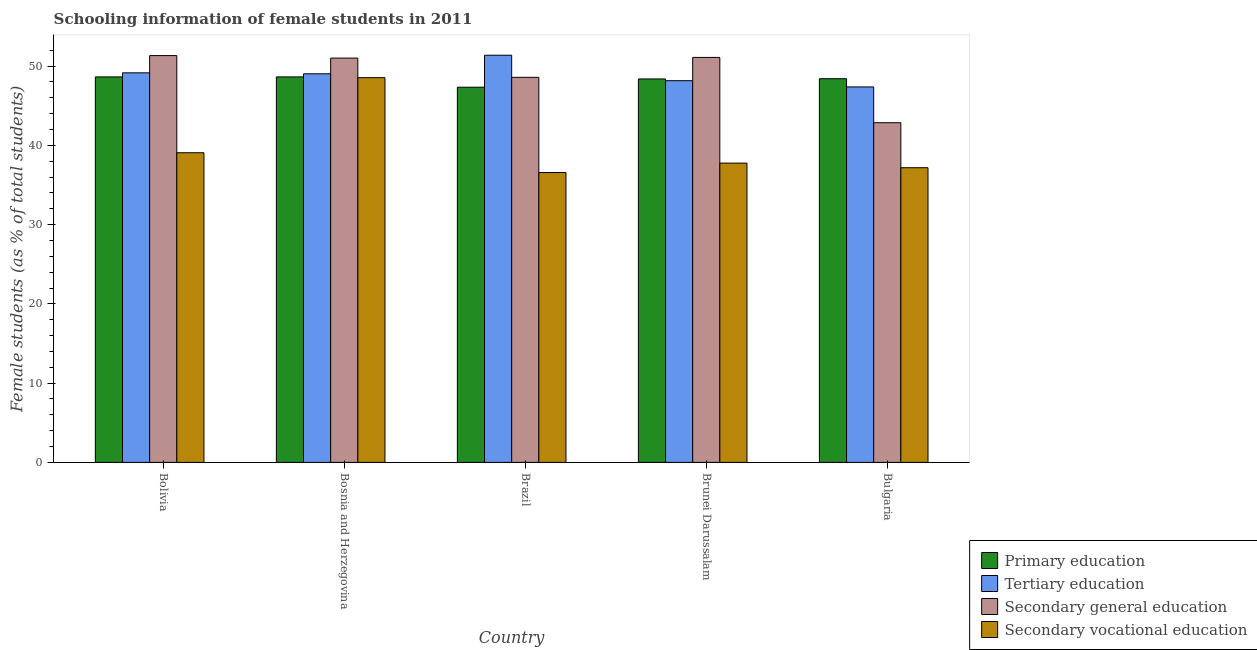How many different coloured bars are there?
Provide a short and direct response. 4. How many groups of bars are there?
Make the answer very short. 5. Are the number of bars per tick equal to the number of legend labels?
Provide a succinct answer. Yes. How many bars are there on the 2nd tick from the left?
Offer a very short reply. 4. How many bars are there on the 2nd tick from the right?
Keep it short and to the point. 4. What is the label of the 1st group of bars from the left?
Provide a succinct answer. Bolivia. What is the percentage of female students in secondary education in Bulgaria?
Provide a succinct answer. 42.86. Across all countries, what is the maximum percentage of female students in primary education?
Offer a terse response. 48.63. Across all countries, what is the minimum percentage of female students in secondary education?
Make the answer very short. 42.86. What is the total percentage of female students in tertiary education in the graph?
Your response must be concise. 245.07. What is the difference between the percentage of female students in primary education in Bolivia and that in Bulgaria?
Your answer should be very brief. 0.23. What is the difference between the percentage of female students in tertiary education in Brunei Darussalam and the percentage of female students in secondary education in Bosnia and Herzegovina?
Make the answer very short. -2.85. What is the average percentage of female students in tertiary education per country?
Your answer should be very brief. 49.01. What is the difference between the percentage of female students in secondary vocational education and percentage of female students in secondary education in Bulgaria?
Give a very brief answer. -5.68. What is the ratio of the percentage of female students in secondary education in Bosnia and Herzegovina to that in Bulgaria?
Make the answer very short. 1.19. Is the difference between the percentage of female students in secondary education in Brazil and Brunei Darussalam greater than the difference between the percentage of female students in secondary vocational education in Brazil and Brunei Darussalam?
Offer a very short reply. No. What is the difference between the highest and the second highest percentage of female students in secondary education?
Provide a short and direct response. 0.23. What is the difference between the highest and the lowest percentage of female students in primary education?
Your response must be concise. 1.3. Is the sum of the percentage of female students in secondary vocational education in Bosnia and Herzegovina and Brazil greater than the maximum percentage of female students in tertiary education across all countries?
Offer a terse response. Yes. Is it the case that in every country, the sum of the percentage of female students in secondary vocational education and percentage of female students in primary education is greater than the sum of percentage of female students in tertiary education and percentage of female students in secondary education?
Ensure brevity in your answer.  Yes. What does the 1st bar from the left in Brazil represents?
Ensure brevity in your answer.  Primary education. What does the 1st bar from the right in Brazil represents?
Offer a terse response. Secondary vocational education. Is it the case that in every country, the sum of the percentage of female students in primary education and percentage of female students in tertiary education is greater than the percentage of female students in secondary education?
Offer a very short reply. Yes. Are all the bars in the graph horizontal?
Provide a short and direct response. No. How many countries are there in the graph?
Provide a short and direct response. 5. What is the difference between two consecutive major ticks on the Y-axis?
Keep it short and to the point. 10. Are the values on the major ticks of Y-axis written in scientific E-notation?
Your answer should be very brief. No. Does the graph contain grids?
Keep it short and to the point. No. Where does the legend appear in the graph?
Provide a short and direct response. Bottom right. How many legend labels are there?
Make the answer very short. 4. How are the legend labels stacked?
Provide a short and direct response. Vertical. What is the title of the graph?
Offer a terse response. Schooling information of female students in 2011. What is the label or title of the Y-axis?
Offer a terse response. Female students (as % of total students). What is the Female students (as % of total students) in Primary education in Bolivia?
Your answer should be compact. 48.63. What is the Female students (as % of total students) in Tertiary education in Bolivia?
Your answer should be very brief. 49.15. What is the Female students (as % of total students) of Secondary general education in Bolivia?
Give a very brief answer. 51.32. What is the Female students (as % of total students) of Secondary vocational education in Bolivia?
Offer a terse response. 39.06. What is the Female students (as % of total students) in Primary education in Bosnia and Herzegovina?
Provide a short and direct response. 48.63. What is the Female students (as % of total students) in Tertiary education in Bosnia and Herzegovina?
Offer a terse response. 49.03. What is the Female students (as % of total students) of Secondary general education in Bosnia and Herzegovina?
Your answer should be compact. 51.01. What is the Female students (as % of total students) of Secondary vocational education in Bosnia and Herzegovina?
Offer a terse response. 48.54. What is the Female students (as % of total students) of Primary education in Brazil?
Your answer should be very brief. 47.33. What is the Female students (as % of total students) in Tertiary education in Brazil?
Ensure brevity in your answer.  51.37. What is the Female students (as % of total students) in Secondary general education in Brazil?
Provide a succinct answer. 48.58. What is the Female students (as % of total students) of Secondary vocational education in Brazil?
Offer a terse response. 36.57. What is the Female students (as % of total students) in Primary education in Brunei Darussalam?
Your response must be concise. 48.38. What is the Female students (as % of total students) in Tertiary education in Brunei Darussalam?
Your response must be concise. 48.15. What is the Female students (as % of total students) of Secondary general education in Brunei Darussalam?
Your answer should be compact. 51.09. What is the Female students (as % of total students) of Secondary vocational education in Brunei Darussalam?
Your response must be concise. 37.76. What is the Female students (as % of total students) in Primary education in Bulgaria?
Provide a short and direct response. 48.4. What is the Female students (as % of total students) of Tertiary education in Bulgaria?
Your response must be concise. 47.37. What is the Female students (as % of total students) of Secondary general education in Bulgaria?
Provide a short and direct response. 42.86. What is the Female students (as % of total students) in Secondary vocational education in Bulgaria?
Your response must be concise. 37.17. Across all countries, what is the maximum Female students (as % of total students) in Primary education?
Your answer should be very brief. 48.63. Across all countries, what is the maximum Female students (as % of total students) of Tertiary education?
Your response must be concise. 51.37. Across all countries, what is the maximum Female students (as % of total students) of Secondary general education?
Make the answer very short. 51.32. Across all countries, what is the maximum Female students (as % of total students) in Secondary vocational education?
Offer a very short reply. 48.54. Across all countries, what is the minimum Female students (as % of total students) in Primary education?
Offer a very short reply. 47.33. Across all countries, what is the minimum Female students (as % of total students) of Tertiary education?
Keep it short and to the point. 47.37. Across all countries, what is the minimum Female students (as % of total students) in Secondary general education?
Ensure brevity in your answer.  42.86. Across all countries, what is the minimum Female students (as % of total students) in Secondary vocational education?
Provide a short and direct response. 36.57. What is the total Female students (as % of total students) in Primary education in the graph?
Provide a short and direct response. 241.38. What is the total Female students (as % of total students) in Tertiary education in the graph?
Your answer should be very brief. 245.07. What is the total Female students (as % of total students) in Secondary general education in the graph?
Ensure brevity in your answer.  244.86. What is the total Female students (as % of total students) in Secondary vocational education in the graph?
Give a very brief answer. 199.11. What is the difference between the Female students (as % of total students) in Primary education in Bolivia and that in Bosnia and Herzegovina?
Make the answer very short. -0. What is the difference between the Female students (as % of total students) in Tertiary education in Bolivia and that in Bosnia and Herzegovina?
Your answer should be compact. 0.12. What is the difference between the Female students (as % of total students) in Secondary general education in Bolivia and that in Bosnia and Herzegovina?
Your answer should be compact. 0.32. What is the difference between the Female students (as % of total students) of Secondary vocational education in Bolivia and that in Bosnia and Herzegovina?
Your response must be concise. -9.47. What is the difference between the Female students (as % of total students) in Primary education in Bolivia and that in Brazil?
Ensure brevity in your answer.  1.3. What is the difference between the Female students (as % of total students) of Tertiary education in Bolivia and that in Brazil?
Provide a short and direct response. -2.22. What is the difference between the Female students (as % of total students) of Secondary general education in Bolivia and that in Brazil?
Provide a succinct answer. 2.74. What is the difference between the Female students (as % of total students) in Secondary vocational education in Bolivia and that in Brazil?
Provide a short and direct response. 2.49. What is the difference between the Female students (as % of total students) of Primary education in Bolivia and that in Brunei Darussalam?
Your answer should be very brief. 0.26. What is the difference between the Female students (as % of total students) of Secondary general education in Bolivia and that in Brunei Darussalam?
Make the answer very short. 0.23. What is the difference between the Female students (as % of total students) in Secondary vocational education in Bolivia and that in Brunei Darussalam?
Keep it short and to the point. 1.31. What is the difference between the Female students (as % of total students) of Primary education in Bolivia and that in Bulgaria?
Offer a terse response. 0.23. What is the difference between the Female students (as % of total students) in Tertiary education in Bolivia and that in Bulgaria?
Your response must be concise. 1.78. What is the difference between the Female students (as % of total students) of Secondary general education in Bolivia and that in Bulgaria?
Ensure brevity in your answer.  8.47. What is the difference between the Female students (as % of total students) in Secondary vocational education in Bolivia and that in Bulgaria?
Offer a very short reply. 1.89. What is the difference between the Female students (as % of total students) of Primary education in Bosnia and Herzegovina and that in Brazil?
Your answer should be very brief. 1.3. What is the difference between the Female students (as % of total students) in Tertiary education in Bosnia and Herzegovina and that in Brazil?
Make the answer very short. -2.34. What is the difference between the Female students (as % of total students) in Secondary general education in Bosnia and Herzegovina and that in Brazil?
Offer a very short reply. 2.43. What is the difference between the Female students (as % of total students) in Secondary vocational education in Bosnia and Herzegovina and that in Brazil?
Keep it short and to the point. 11.97. What is the difference between the Female students (as % of total students) in Primary education in Bosnia and Herzegovina and that in Brunei Darussalam?
Your answer should be very brief. 0.26. What is the difference between the Female students (as % of total students) in Tertiary education in Bosnia and Herzegovina and that in Brunei Darussalam?
Your answer should be compact. 0.87. What is the difference between the Female students (as % of total students) in Secondary general education in Bosnia and Herzegovina and that in Brunei Darussalam?
Give a very brief answer. -0.09. What is the difference between the Female students (as % of total students) in Secondary vocational education in Bosnia and Herzegovina and that in Brunei Darussalam?
Provide a succinct answer. 10.78. What is the difference between the Female students (as % of total students) in Primary education in Bosnia and Herzegovina and that in Bulgaria?
Your answer should be compact. 0.23. What is the difference between the Female students (as % of total students) of Tertiary education in Bosnia and Herzegovina and that in Bulgaria?
Offer a terse response. 1.66. What is the difference between the Female students (as % of total students) in Secondary general education in Bosnia and Herzegovina and that in Bulgaria?
Provide a short and direct response. 8.15. What is the difference between the Female students (as % of total students) of Secondary vocational education in Bosnia and Herzegovina and that in Bulgaria?
Your response must be concise. 11.36. What is the difference between the Female students (as % of total students) in Primary education in Brazil and that in Brunei Darussalam?
Give a very brief answer. -1.04. What is the difference between the Female students (as % of total students) of Tertiary education in Brazil and that in Brunei Darussalam?
Provide a succinct answer. 3.21. What is the difference between the Female students (as % of total students) in Secondary general education in Brazil and that in Brunei Darussalam?
Offer a very short reply. -2.51. What is the difference between the Female students (as % of total students) in Secondary vocational education in Brazil and that in Brunei Darussalam?
Give a very brief answer. -1.19. What is the difference between the Female students (as % of total students) of Primary education in Brazil and that in Bulgaria?
Ensure brevity in your answer.  -1.07. What is the difference between the Female students (as % of total students) of Tertiary education in Brazil and that in Bulgaria?
Your response must be concise. 4. What is the difference between the Female students (as % of total students) of Secondary general education in Brazil and that in Bulgaria?
Keep it short and to the point. 5.72. What is the difference between the Female students (as % of total students) in Secondary vocational education in Brazil and that in Bulgaria?
Your response must be concise. -0.6. What is the difference between the Female students (as % of total students) in Primary education in Brunei Darussalam and that in Bulgaria?
Provide a short and direct response. -0.03. What is the difference between the Female students (as % of total students) in Tertiary education in Brunei Darussalam and that in Bulgaria?
Your response must be concise. 0.79. What is the difference between the Female students (as % of total students) of Secondary general education in Brunei Darussalam and that in Bulgaria?
Keep it short and to the point. 8.24. What is the difference between the Female students (as % of total students) in Secondary vocational education in Brunei Darussalam and that in Bulgaria?
Give a very brief answer. 0.58. What is the difference between the Female students (as % of total students) of Primary education in Bolivia and the Female students (as % of total students) of Tertiary education in Bosnia and Herzegovina?
Ensure brevity in your answer.  -0.4. What is the difference between the Female students (as % of total students) of Primary education in Bolivia and the Female students (as % of total students) of Secondary general education in Bosnia and Herzegovina?
Provide a succinct answer. -2.38. What is the difference between the Female students (as % of total students) in Primary education in Bolivia and the Female students (as % of total students) in Secondary vocational education in Bosnia and Herzegovina?
Your answer should be very brief. 0.09. What is the difference between the Female students (as % of total students) of Tertiary education in Bolivia and the Female students (as % of total students) of Secondary general education in Bosnia and Herzegovina?
Ensure brevity in your answer.  -1.86. What is the difference between the Female students (as % of total students) of Tertiary education in Bolivia and the Female students (as % of total students) of Secondary vocational education in Bosnia and Herzegovina?
Your answer should be very brief. 0.61. What is the difference between the Female students (as % of total students) of Secondary general education in Bolivia and the Female students (as % of total students) of Secondary vocational education in Bosnia and Herzegovina?
Your answer should be compact. 2.79. What is the difference between the Female students (as % of total students) of Primary education in Bolivia and the Female students (as % of total students) of Tertiary education in Brazil?
Offer a terse response. -2.74. What is the difference between the Female students (as % of total students) of Primary education in Bolivia and the Female students (as % of total students) of Secondary general education in Brazil?
Your response must be concise. 0.05. What is the difference between the Female students (as % of total students) of Primary education in Bolivia and the Female students (as % of total students) of Secondary vocational education in Brazil?
Keep it short and to the point. 12.06. What is the difference between the Female students (as % of total students) of Tertiary education in Bolivia and the Female students (as % of total students) of Secondary general education in Brazil?
Offer a very short reply. 0.57. What is the difference between the Female students (as % of total students) of Tertiary education in Bolivia and the Female students (as % of total students) of Secondary vocational education in Brazil?
Keep it short and to the point. 12.58. What is the difference between the Female students (as % of total students) in Secondary general education in Bolivia and the Female students (as % of total students) in Secondary vocational education in Brazil?
Offer a very short reply. 14.75. What is the difference between the Female students (as % of total students) of Primary education in Bolivia and the Female students (as % of total students) of Tertiary education in Brunei Darussalam?
Ensure brevity in your answer.  0.48. What is the difference between the Female students (as % of total students) of Primary education in Bolivia and the Female students (as % of total students) of Secondary general education in Brunei Darussalam?
Give a very brief answer. -2.46. What is the difference between the Female students (as % of total students) of Primary education in Bolivia and the Female students (as % of total students) of Secondary vocational education in Brunei Darussalam?
Give a very brief answer. 10.87. What is the difference between the Female students (as % of total students) of Tertiary education in Bolivia and the Female students (as % of total students) of Secondary general education in Brunei Darussalam?
Ensure brevity in your answer.  -1.95. What is the difference between the Female students (as % of total students) of Tertiary education in Bolivia and the Female students (as % of total students) of Secondary vocational education in Brunei Darussalam?
Offer a terse response. 11.39. What is the difference between the Female students (as % of total students) of Secondary general education in Bolivia and the Female students (as % of total students) of Secondary vocational education in Brunei Darussalam?
Keep it short and to the point. 13.56. What is the difference between the Female students (as % of total students) in Primary education in Bolivia and the Female students (as % of total students) in Tertiary education in Bulgaria?
Give a very brief answer. 1.26. What is the difference between the Female students (as % of total students) in Primary education in Bolivia and the Female students (as % of total students) in Secondary general education in Bulgaria?
Keep it short and to the point. 5.78. What is the difference between the Female students (as % of total students) in Primary education in Bolivia and the Female students (as % of total students) in Secondary vocational education in Bulgaria?
Your answer should be compact. 11.46. What is the difference between the Female students (as % of total students) in Tertiary education in Bolivia and the Female students (as % of total students) in Secondary general education in Bulgaria?
Make the answer very short. 6.29. What is the difference between the Female students (as % of total students) of Tertiary education in Bolivia and the Female students (as % of total students) of Secondary vocational education in Bulgaria?
Provide a succinct answer. 11.97. What is the difference between the Female students (as % of total students) in Secondary general education in Bolivia and the Female students (as % of total students) in Secondary vocational education in Bulgaria?
Your answer should be compact. 14.15. What is the difference between the Female students (as % of total students) of Primary education in Bosnia and Herzegovina and the Female students (as % of total students) of Tertiary education in Brazil?
Your response must be concise. -2.73. What is the difference between the Female students (as % of total students) of Primary education in Bosnia and Herzegovina and the Female students (as % of total students) of Secondary general education in Brazil?
Keep it short and to the point. 0.05. What is the difference between the Female students (as % of total students) in Primary education in Bosnia and Herzegovina and the Female students (as % of total students) in Secondary vocational education in Brazil?
Offer a very short reply. 12.06. What is the difference between the Female students (as % of total students) of Tertiary education in Bosnia and Herzegovina and the Female students (as % of total students) of Secondary general education in Brazil?
Give a very brief answer. 0.45. What is the difference between the Female students (as % of total students) of Tertiary education in Bosnia and Herzegovina and the Female students (as % of total students) of Secondary vocational education in Brazil?
Your answer should be compact. 12.46. What is the difference between the Female students (as % of total students) of Secondary general education in Bosnia and Herzegovina and the Female students (as % of total students) of Secondary vocational education in Brazil?
Your response must be concise. 14.44. What is the difference between the Female students (as % of total students) of Primary education in Bosnia and Herzegovina and the Female students (as % of total students) of Tertiary education in Brunei Darussalam?
Provide a short and direct response. 0.48. What is the difference between the Female students (as % of total students) in Primary education in Bosnia and Herzegovina and the Female students (as % of total students) in Secondary general education in Brunei Darussalam?
Keep it short and to the point. -2.46. What is the difference between the Female students (as % of total students) of Primary education in Bosnia and Herzegovina and the Female students (as % of total students) of Secondary vocational education in Brunei Darussalam?
Your response must be concise. 10.87. What is the difference between the Female students (as % of total students) in Tertiary education in Bosnia and Herzegovina and the Female students (as % of total students) in Secondary general education in Brunei Darussalam?
Give a very brief answer. -2.07. What is the difference between the Female students (as % of total students) in Tertiary education in Bosnia and Herzegovina and the Female students (as % of total students) in Secondary vocational education in Brunei Darussalam?
Give a very brief answer. 11.27. What is the difference between the Female students (as % of total students) in Secondary general education in Bosnia and Herzegovina and the Female students (as % of total students) in Secondary vocational education in Brunei Darussalam?
Your response must be concise. 13.25. What is the difference between the Female students (as % of total students) of Primary education in Bosnia and Herzegovina and the Female students (as % of total students) of Tertiary education in Bulgaria?
Provide a short and direct response. 1.26. What is the difference between the Female students (as % of total students) of Primary education in Bosnia and Herzegovina and the Female students (as % of total students) of Secondary general education in Bulgaria?
Make the answer very short. 5.78. What is the difference between the Female students (as % of total students) of Primary education in Bosnia and Herzegovina and the Female students (as % of total students) of Secondary vocational education in Bulgaria?
Your answer should be very brief. 11.46. What is the difference between the Female students (as % of total students) in Tertiary education in Bosnia and Herzegovina and the Female students (as % of total students) in Secondary general education in Bulgaria?
Your response must be concise. 6.17. What is the difference between the Female students (as % of total students) of Tertiary education in Bosnia and Herzegovina and the Female students (as % of total students) of Secondary vocational education in Bulgaria?
Your answer should be compact. 11.85. What is the difference between the Female students (as % of total students) of Secondary general education in Bosnia and Herzegovina and the Female students (as % of total students) of Secondary vocational education in Bulgaria?
Offer a very short reply. 13.83. What is the difference between the Female students (as % of total students) of Primary education in Brazil and the Female students (as % of total students) of Tertiary education in Brunei Darussalam?
Your response must be concise. -0.82. What is the difference between the Female students (as % of total students) of Primary education in Brazil and the Female students (as % of total students) of Secondary general education in Brunei Darussalam?
Make the answer very short. -3.76. What is the difference between the Female students (as % of total students) in Primary education in Brazil and the Female students (as % of total students) in Secondary vocational education in Brunei Darussalam?
Make the answer very short. 9.57. What is the difference between the Female students (as % of total students) of Tertiary education in Brazil and the Female students (as % of total students) of Secondary general education in Brunei Darussalam?
Your answer should be compact. 0.27. What is the difference between the Female students (as % of total students) of Tertiary education in Brazil and the Female students (as % of total students) of Secondary vocational education in Brunei Darussalam?
Give a very brief answer. 13.61. What is the difference between the Female students (as % of total students) of Secondary general education in Brazil and the Female students (as % of total students) of Secondary vocational education in Brunei Darussalam?
Your answer should be very brief. 10.82. What is the difference between the Female students (as % of total students) in Primary education in Brazil and the Female students (as % of total students) in Tertiary education in Bulgaria?
Make the answer very short. -0.04. What is the difference between the Female students (as % of total students) in Primary education in Brazil and the Female students (as % of total students) in Secondary general education in Bulgaria?
Provide a succinct answer. 4.48. What is the difference between the Female students (as % of total students) of Primary education in Brazil and the Female students (as % of total students) of Secondary vocational education in Bulgaria?
Your answer should be very brief. 10.16. What is the difference between the Female students (as % of total students) in Tertiary education in Brazil and the Female students (as % of total students) in Secondary general education in Bulgaria?
Ensure brevity in your answer.  8.51. What is the difference between the Female students (as % of total students) in Tertiary education in Brazil and the Female students (as % of total students) in Secondary vocational education in Bulgaria?
Your response must be concise. 14.19. What is the difference between the Female students (as % of total students) of Secondary general education in Brazil and the Female students (as % of total students) of Secondary vocational education in Bulgaria?
Your response must be concise. 11.4. What is the difference between the Female students (as % of total students) of Primary education in Brunei Darussalam and the Female students (as % of total students) of Tertiary education in Bulgaria?
Your response must be concise. 1.01. What is the difference between the Female students (as % of total students) in Primary education in Brunei Darussalam and the Female students (as % of total students) in Secondary general education in Bulgaria?
Your response must be concise. 5.52. What is the difference between the Female students (as % of total students) of Primary education in Brunei Darussalam and the Female students (as % of total students) of Secondary vocational education in Bulgaria?
Make the answer very short. 11.2. What is the difference between the Female students (as % of total students) of Tertiary education in Brunei Darussalam and the Female students (as % of total students) of Secondary general education in Bulgaria?
Your answer should be very brief. 5.3. What is the difference between the Female students (as % of total students) in Tertiary education in Brunei Darussalam and the Female students (as % of total students) in Secondary vocational education in Bulgaria?
Keep it short and to the point. 10.98. What is the difference between the Female students (as % of total students) in Secondary general education in Brunei Darussalam and the Female students (as % of total students) in Secondary vocational education in Bulgaria?
Give a very brief answer. 13.92. What is the average Female students (as % of total students) in Primary education per country?
Ensure brevity in your answer.  48.28. What is the average Female students (as % of total students) in Tertiary education per country?
Provide a succinct answer. 49.01. What is the average Female students (as % of total students) in Secondary general education per country?
Your response must be concise. 48.97. What is the average Female students (as % of total students) of Secondary vocational education per country?
Provide a succinct answer. 39.82. What is the difference between the Female students (as % of total students) of Primary education and Female students (as % of total students) of Tertiary education in Bolivia?
Provide a succinct answer. -0.52. What is the difference between the Female students (as % of total students) in Primary education and Female students (as % of total students) in Secondary general education in Bolivia?
Provide a short and direct response. -2.69. What is the difference between the Female students (as % of total students) in Primary education and Female students (as % of total students) in Secondary vocational education in Bolivia?
Keep it short and to the point. 9.57. What is the difference between the Female students (as % of total students) in Tertiary education and Female students (as % of total students) in Secondary general education in Bolivia?
Keep it short and to the point. -2.18. What is the difference between the Female students (as % of total students) of Tertiary education and Female students (as % of total students) of Secondary vocational education in Bolivia?
Keep it short and to the point. 10.08. What is the difference between the Female students (as % of total students) in Secondary general education and Female students (as % of total students) in Secondary vocational education in Bolivia?
Make the answer very short. 12.26. What is the difference between the Female students (as % of total students) in Primary education and Female students (as % of total students) in Tertiary education in Bosnia and Herzegovina?
Offer a very short reply. -0.39. What is the difference between the Female students (as % of total students) of Primary education and Female students (as % of total students) of Secondary general education in Bosnia and Herzegovina?
Ensure brevity in your answer.  -2.37. What is the difference between the Female students (as % of total students) in Primary education and Female students (as % of total students) in Secondary vocational education in Bosnia and Herzegovina?
Your response must be concise. 0.1. What is the difference between the Female students (as % of total students) in Tertiary education and Female students (as % of total students) in Secondary general education in Bosnia and Herzegovina?
Your response must be concise. -1.98. What is the difference between the Female students (as % of total students) in Tertiary education and Female students (as % of total students) in Secondary vocational education in Bosnia and Herzegovina?
Give a very brief answer. 0.49. What is the difference between the Female students (as % of total students) in Secondary general education and Female students (as % of total students) in Secondary vocational education in Bosnia and Herzegovina?
Your answer should be compact. 2.47. What is the difference between the Female students (as % of total students) of Primary education and Female students (as % of total students) of Tertiary education in Brazil?
Make the answer very short. -4.03. What is the difference between the Female students (as % of total students) in Primary education and Female students (as % of total students) in Secondary general education in Brazil?
Offer a terse response. -1.25. What is the difference between the Female students (as % of total students) of Primary education and Female students (as % of total students) of Secondary vocational education in Brazil?
Offer a very short reply. 10.76. What is the difference between the Female students (as % of total students) of Tertiary education and Female students (as % of total students) of Secondary general education in Brazil?
Your answer should be compact. 2.79. What is the difference between the Female students (as % of total students) in Tertiary education and Female students (as % of total students) in Secondary vocational education in Brazil?
Your answer should be compact. 14.8. What is the difference between the Female students (as % of total students) in Secondary general education and Female students (as % of total students) in Secondary vocational education in Brazil?
Offer a very short reply. 12.01. What is the difference between the Female students (as % of total students) in Primary education and Female students (as % of total students) in Tertiary education in Brunei Darussalam?
Provide a succinct answer. 0.22. What is the difference between the Female students (as % of total students) of Primary education and Female students (as % of total students) of Secondary general education in Brunei Darussalam?
Your answer should be compact. -2.72. What is the difference between the Female students (as % of total students) in Primary education and Female students (as % of total students) in Secondary vocational education in Brunei Darussalam?
Give a very brief answer. 10.62. What is the difference between the Female students (as % of total students) of Tertiary education and Female students (as % of total students) of Secondary general education in Brunei Darussalam?
Offer a very short reply. -2.94. What is the difference between the Female students (as % of total students) in Tertiary education and Female students (as % of total students) in Secondary vocational education in Brunei Darussalam?
Offer a very short reply. 10.4. What is the difference between the Female students (as % of total students) in Secondary general education and Female students (as % of total students) in Secondary vocational education in Brunei Darussalam?
Ensure brevity in your answer.  13.33. What is the difference between the Female students (as % of total students) of Primary education and Female students (as % of total students) of Tertiary education in Bulgaria?
Offer a very short reply. 1.04. What is the difference between the Female students (as % of total students) of Primary education and Female students (as % of total students) of Secondary general education in Bulgaria?
Ensure brevity in your answer.  5.55. What is the difference between the Female students (as % of total students) in Primary education and Female students (as % of total students) in Secondary vocational education in Bulgaria?
Your response must be concise. 11.23. What is the difference between the Female students (as % of total students) of Tertiary education and Female students (as % of total students) of Secondary general education in Bulgaria?
Your response must be concise. 4.51. What is the difference between the Female students (as % of total students) in Tertiary education and Female students (as % of total students) in Secondary vocational education in Bulgaria?
Give a very brief answer. 10.19. What is the difference between the Female students (as % of total students) of Secondary general education and Female students (as % of total students) of Secondary vocational education in Bulgaria?
Keep it short and to the point. 5.68. What is the ratio of the Female students (as % of total students) in Tertiary education in Bolivia to that in Bosnia and Herzegovina?
Your answer should be very brief. 1. What is the ratio of the Female students (as % of total students) in Secondary vocational education in Bolivia to that in Bosnia and Herzegovina?
Your answer should be compact. 0.8. What is the ratio of the Female students (as % of total students) of Primary education in Bolivia to that in Brazil?
Give a very brief answer. 1.03. What is the ratio of the Female students (as % of total students) of Tertiary education in Bolivia to that in Brazil?
Your response must be concise. 0.96. What is the ratio of the Female students (as % of total students) in Secondary general education in Bolivia to that in Brazil?
Keep it short and to the point. 1.06. What is the ratio of the Female students (as % of total students) in Secondary vocational education in Bolivia to that in Brazil?
Give a very brief answer. 1.07. What is the ratio of the Female students (as % of total students) in Tertiary education in Bolivia to that in Brunei Darussalam?
Make the answer very short. 1.02. What is the ratio of the Female students (as % of total students) in Secondary vocational education in Bolivia to that in Brunei Darussalam?
Your answer should be compact. 1.03. What is the ratio of the Female students (as % of total students) of Tertiary education in Bolivia to that in Bulgaria?
Offer a terse response. 1.04. What is the ratio of the Female students (as % of total students) in Secondary general education in Bolivia to that in Bulgaria?
Your answer should be very brief. 1.2. What is the ratio of the Female students (as % of total students) in Secondary vocational education in Bolivia to that in Bulgaria?
Keep it short and to the point. 1.05. What is the ratio of the Female students (as % of total students) in Primary education in Bosnia and Herzegovina to that in Brazil?
Give a very brief answer. 1.03. What is the ratio of the Female students (as % of total students) in Tertiary education in Bosnia and Herzegovina to that in Brazil?
Provide a succinct answer. 0.95. What is the ratio of the Female students (as % of total students) of Secondary vocational education in Bosnia and Herzegovina to that in Brazil?
Your answer should be very brief. 1.33. What is the ratio of the Female students (as % of total students) of Primary education in Bosnia and Herzegovina to that in Brunei Darussalam?
Give a very brief answer. 1.01. What is the ratio of the Female students (as % of total students) of Tertiary education in Bosnia and Herzegovina to that in Brunei Darussalam?
Your response must be concise. 1.02. What is the ratio of the Female students (as % of total students) in Secondary general education in Bosnia and Herzegovina to that in Brunei Darussalam?
Offer a terse response. 1. What is the ratio of the Female students (as % of total students) in Secondary vocational education in Bosnia and Herzegovina to that in Brunei Darussalam?
Provide a short and direct response. 1.29. What is the ratio of the Female students (as % of total students) in Tertiary education in Bosnia and Herzegovina to that in Bulgaria?
Your response must be concise. 1.03. What is the ratio of the Female students (as % of total students) of Secondary general education in Bosnia and Herzegovina to that in Bulgaria?
Provide a succinct answer. 1.19. What is the ratio of the Female students (as % of total students) in Secondary vocational education in Bosnia and Herzegovina to that in Bulgaria?
Your answer should be compact. 1.31. What is the ratio of the Female students (as % of total students) in Primary education in Brazil to that in Brunei Darussalam?
Provide a short and direct response. 0.98. What is the ratio of the Female students (as % of total students) in Tertiary education in Brazil to that in Brunei Darussalam?
Your answer should be very brief. 1.07. What is the ratio of the Female students (as % of total students) in Secondary general education in Brazil to that in Brunei Darussalam?
Your answer should be very brief. 0.95. What is the ratio of the Female students (as % of total students) in Secondary vocational education in Brazil to that in Brunei Darussalam?
Give a very brief answer. 0.97. What is the ratio of the Female students (as % of total students) of Primary education in Brazil to that in Bulgaria?
Ensure brevity in your answer.  0.98. What is the ratio of the Female students (as % of total students) of Tertiary education in Brazil to that in Bulgaria?
Give a very brief answer. 1.08. What is the ratio of the Female students (as % of total students) of Secondary general education in Brazil to that in Bulgaria?
Your response must be concise. 1.13. What is the ratio of the Female students (as % of total students) in Secondary vocational education in Brazil to that in Bulgaria?
Make the answer very short. 0.98. What is the ratio of the Female students (as % of total students) in Tertiary education in Brunei Darussalam to that in Bulgaria?
Your answer should be very brief. 1.02. What is the ratio of the Female students (as % of total students) of Secondary general education in Brunei Darussalam to that in Bulgaria?
Your response must be concise. 1.19. What is the ratio of the Female students (as % of total students) of Secondary vocational education in Brunei Darussalam to that in Bulgaria?
Provide a succinct answer. 1.02. What is the difference between the highest and the second highest Female students (as % of total students) of Primary education?
Ensure brevity in your answer.  0. What is the difference between the highest and the second highest Female students (as % of total students) in Tertiary education?
Your answer should be very brief. 2.22. What is the difference between the highest and the second highest Female students (as % of total students) of Secondary general education?
Make the answer very short. 0.23. What is the difference between the highest and the second highest Female students (as % of total students) of Secondary vocational education?
Keep it short and to the point. 9.47. What is the difference between the highest and the lowest Female students (as % of total students) of Primary education?
Your response must be concise. 1.3. What is the difference between the highest and the lowest Female students (as % of total students) of Tertiary education?
Ensure brevity in your answer.  4. What is the difference between the highest and the lowest Female students (as % of total students) of Secondary general education?
Give a very brief answer. 8.47. What is the difference between the highest and the lowest Female students (as % of total students) in Secondary vocational education?
Provide a short and direct response. 11.97. 